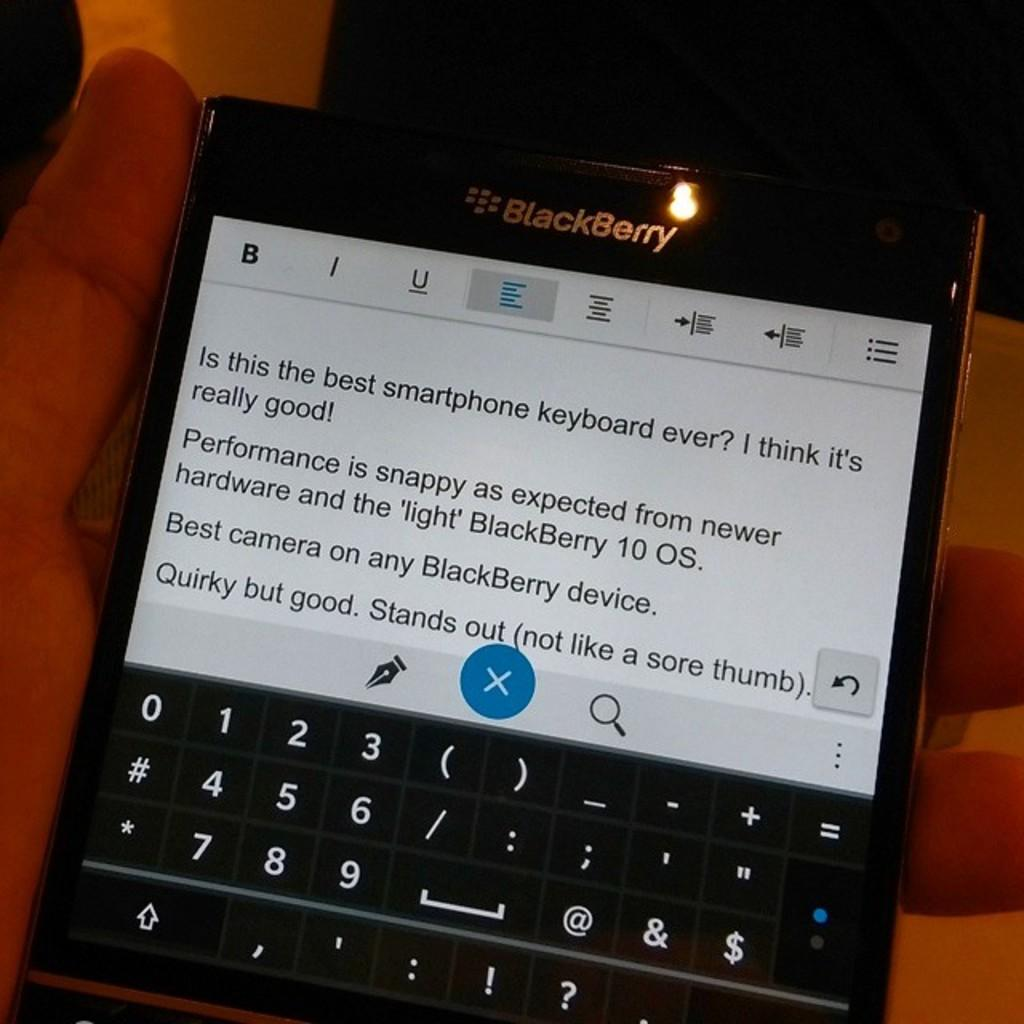What can be seen in the image related to a person's hand? There is a person's hand in the image. What is the hand holding? The hand is holding a device. Can you describe the device? The device has key buttons. What information is visible on the device's screen? There is text visible on the device's screen. How many bubbles can be seen on the person's hand in the image? There are no bubbles present on the person's hand in the image. 